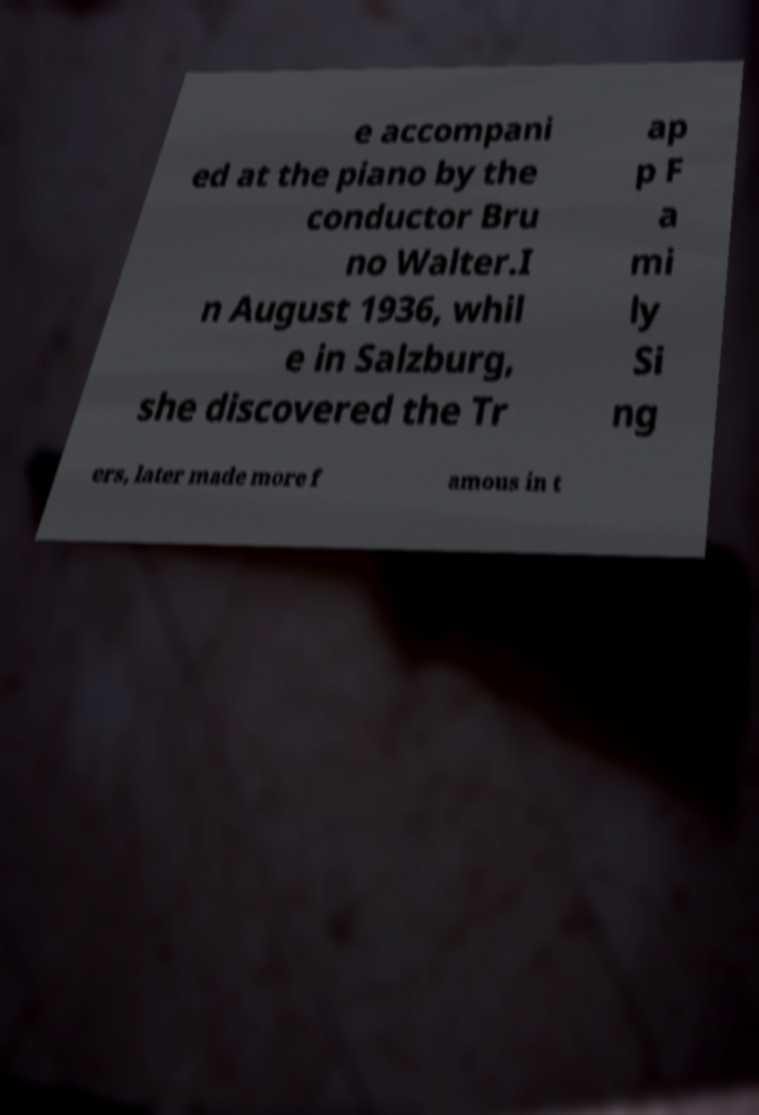Can you accurately transcribe the text from the provided image for me? e accompani ed at the piano by the conductor Bru no Walter.I n August 1936, whil e in Salzburg, she discovered the Tr ap p F a mi ly Si ng ers, later made more f amous in t 